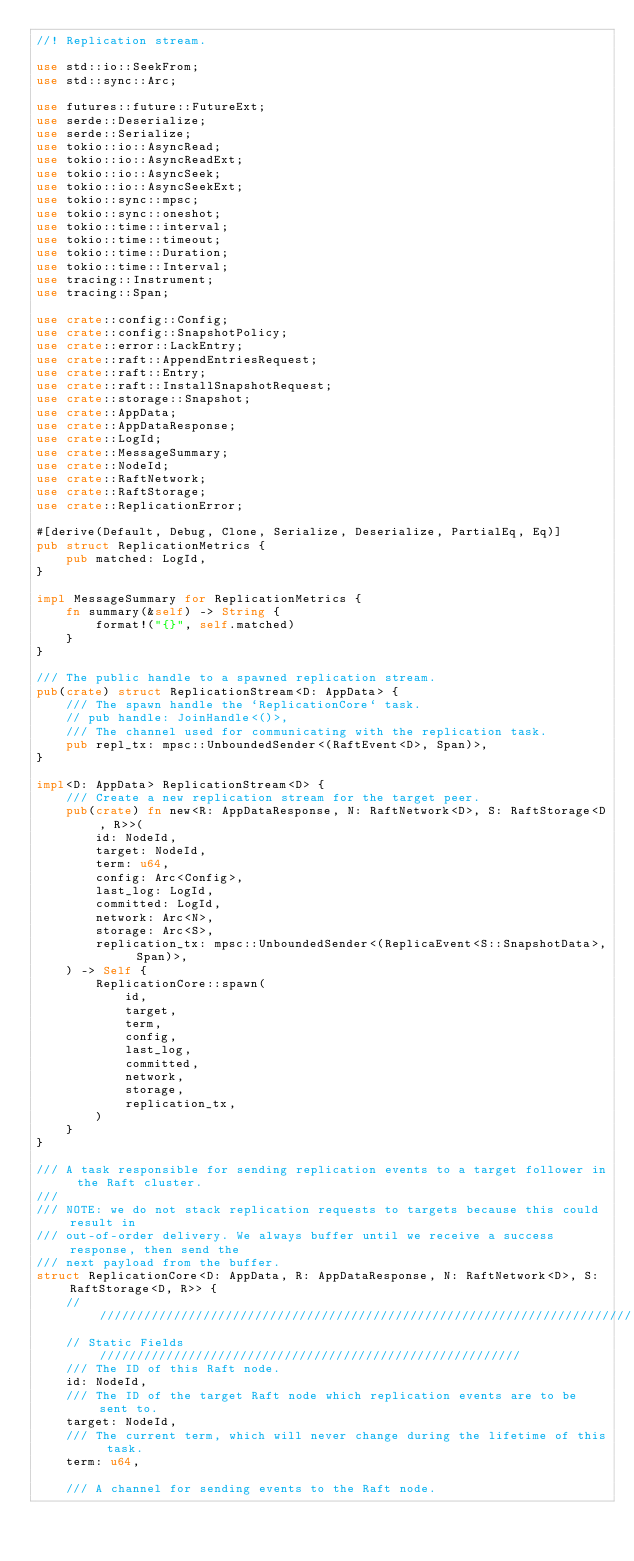<code> <loc_0><loc_0><loc_500><loc_500><_Rust_>//! Replication stream.

use std::io::SeekFrom;
use std::sync::Arc;

use futures::future::FutureExt;
use serde::Deserialize;
use serde::Serialize;
use tokio::io::AsyncRead;
use tokio::io::AsyncReadExt;
use tokio::io::AsyncSeek;
use tokio::io::AsyncSeekExt;
use tokio::sync::mpsc;
use tokio::sync::oneshot;
use tokio::time::interval;
use tokio::time::timeout;
use tokio::time::Duration;
use tokio::time::Interval;
use tracing::Instrument;
use tracing::Span;

use crate::config::Config;
use crate::config::SnapshotPolicy;
use crate::error::LackEntry;
use crate::raft::AppendEntriesRequest;
use crate::raft::Entry;
use crate::raft::InstallSnapshotRequest;
use crate::storage::Snapshot;
use crate::AppData;
use crate::AppDataResponse;
use crate::LogId;
use crate::MessageSummary;
use crate::NodeId;
use crate::RaftNetwork;
use crate::RaftStorage;
use crate::ReplicationError;

#[derive(Default, Debug, Clone, Serialize, Deserialize, PartialEq, Eq)]
pub struct ReplicationMetrics {
    pub matched: LogId,
}

impl MessageSummary for ReplicationMetrics {
    fn summary(&self) -> String {
        format!("{}", self.matched)
    }
}

/// The public handle to a spawned replication stream.
pub(crate) struct ReplicationStream<D: AppData> {
    /// The spawn handle the `ReplicationCore` task.
    // pub handle: JoinHandle<()>,
    /// The channel used for communicating with the replication task.
    pub repl_tx: mpsc::UnboundedSender<(RaftEvent<D>, Span)>,
}

impl<D: AppData> ReplicationStream<D> {
    /// Create a new replication stream for the target peer.
    pub(crate) fn new<R: AppDataResponse, N: RaftNetwork<D>, S: RaftStorage<D, R>>(
        id: NodeId,
        target: NodeId,
        term: u64,
        config: Arc<Config>,
        last_log: LogId,
        committed: LogId,
        network: Arc<N>,
        storage: Arc<S>,
        replication_tx: mpsc::UnboundedSender<(ReplicaEvent<S::SnapshotData>, Span)>,
    ) -> Self {
        ReplicationCore::spawn(
            id,
            target,
            term,
            config,
            last_log,
            committed,
            network,
            storage,
            replication_tx,
        )
    }
}

/// A task responsible for sending replication events to a target follower in the Raft cluster.
///
/// NOTE: we do not stack replication requests to targets because this could result in
/// out-of-order delivery. We always buffer until we receive a success response, then send the
/// next payload from the buffer.
struct ReplicationCore<D: AppData, R: AppDataResponse, N: RaftNetwork<D>, S: RaftStorage<D, R>> {
    //////////////////////////////////////////////////////////////////////////
    // Static Fields /////////////////////////////////////////////////////////
    /// The ID of this Raft node.
    id: NodeId,
    /// The ID of the target Raft node which replication events are to be sent to.
    target: NodeId,
    /// The current term, which will never change during the lifetime of this task.
    term: u64,

    /// A channel for sending events to the Raft node.</code> 